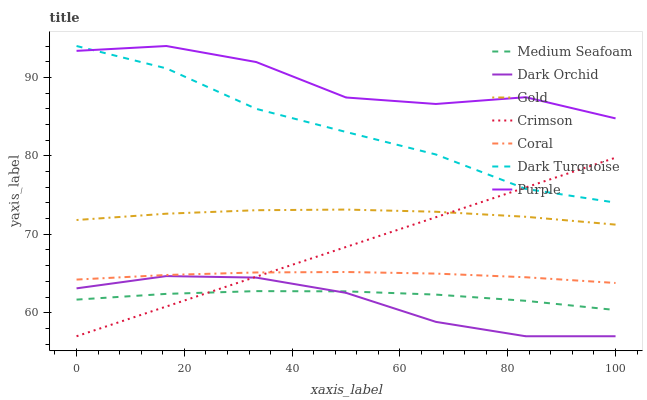Does Dark Orchid have the minimum area under the curve?
Answer yes or no. Yes. Does Purple have the maximum area under the curve?
Answer yes or no. Yes. Does Dark Turquoise have the minimum area under the curve?
Answer yes or no. No. Does Dark Turquoise have the maximum area under the curve?
Answer yes or no. No. Is Crimson the smoothest?
Answer yes or no. Yes. Is Purple the roughest?
Answer yes or no. Yes. Is Dark Turquoise the smoothest?
Answer yes or no. No. Is Dark Turquoise the roughest?
Answer yes or no. No. Does Dark Turquoise have the lowest value?
Answer yes or no. No. Does Dark Turquoise have the highest value?
Answer yes or no. Yes. Does Coral have the highest value?
Answer yes or no. No. Is Medium Seafoam less than Gold?
Answer yes or no. Yes. Is Gold greater than Medium Seafoam?
Answer yes or no. Yes. Does Coral intersect Crimson?
Answer yes or no. Yes. Is Coral less than Crimson?
Answer yes or no. No. Is Coral greater than Crimson?
Answer yes or no. No. Does Medium Seafoam intersect Gold?
Answer yes or no. No. 